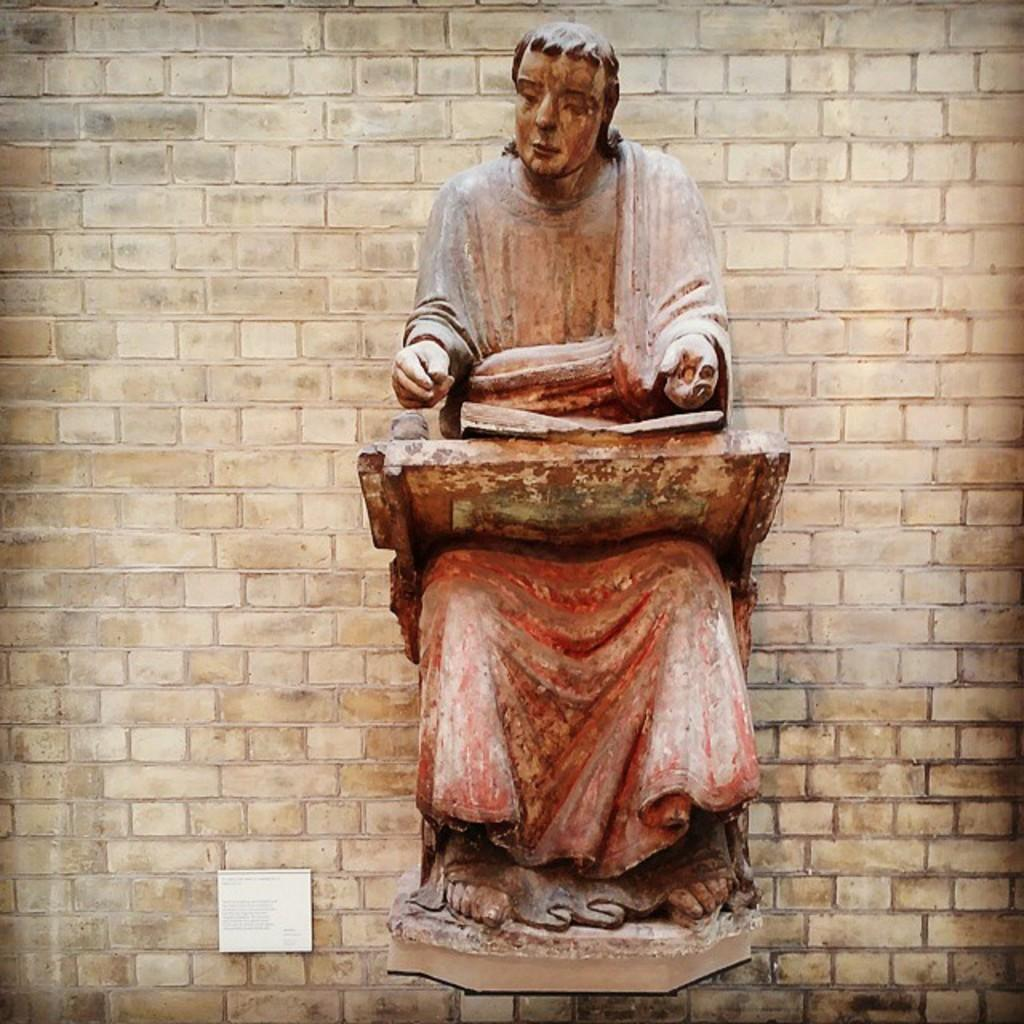What is the main object in the image? There is a statue in the image. What other object can be seen in the image? There is a white board in the image. What color is the wall in the background? The wall in the background is cream-colored. What is written on the white board? There is writing on the white board. How many balloons are tied to the statue in the image? There are no balloons present in the image. Can you describe the stretch of the girl's arms in the image? There is no girl present in the image. 